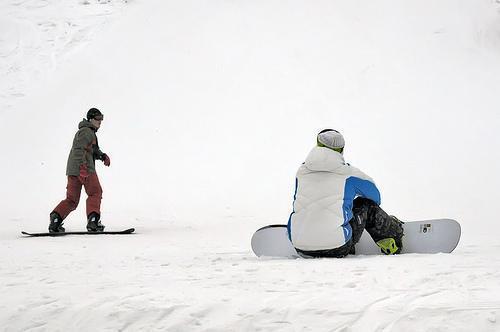How many people are there?
Give a very brief answer. 2. 